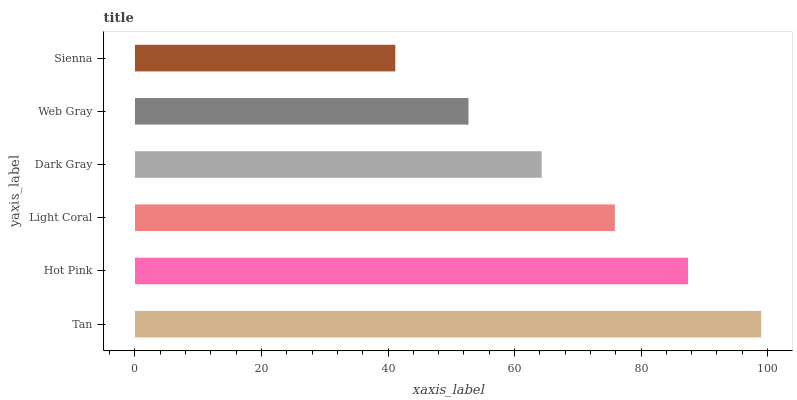Is Sienna the minimum?
Answer yes or no. Yes. Is Tan the maximum?
Answer yes or no. Yes. Is Hot Pink the minimum?
Answer yes or no. No. Is Hot Pink the maximum?
Answer yes or no. No. Is Tan greater than Hot Pink?
Answer yes or no. Yes. Is Hot Pink less than Tan?
Answer yes or no. Yes. Is Hot Pink greater than Tan?
Answer yes or no. No. Is Tan less than Hot Pink?
Answer yes or no. No. Is Light Coral the high median?
Answer yes or no. Yes. Is Dark Gray the low median?
Answer yes or no. Yes. Is Hot Pink the high median?
Answer yes or no. No. Is Sienna the low median?
Answer yes or no. No. 